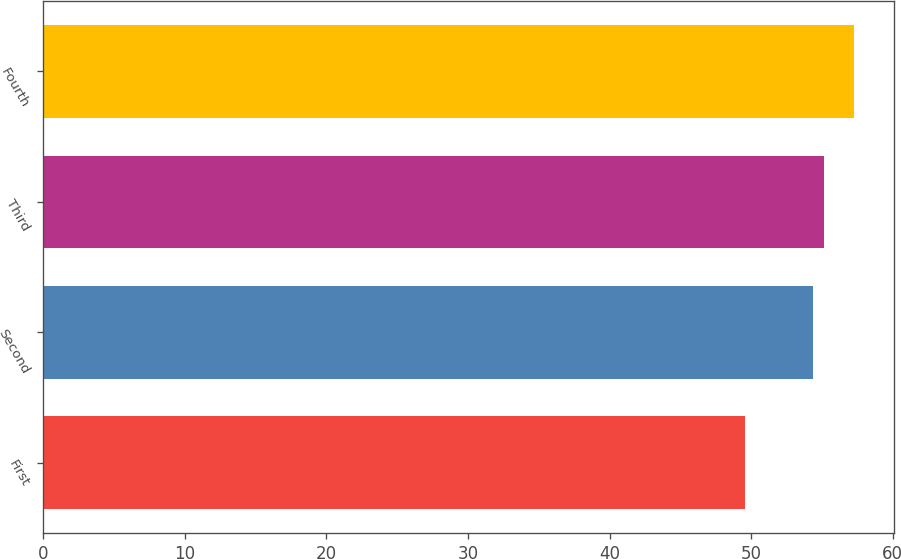Convert chart to OTSL. <chart><loc_0><loc_0><loc_500><loc_500><bar_chart><fcel>First<fcel>Second<fcel>Third<fcel>Fourth<nl><fcel>49.55<fcel>54.38<fcel>55.15<fcel>57.24<nl></chart> 